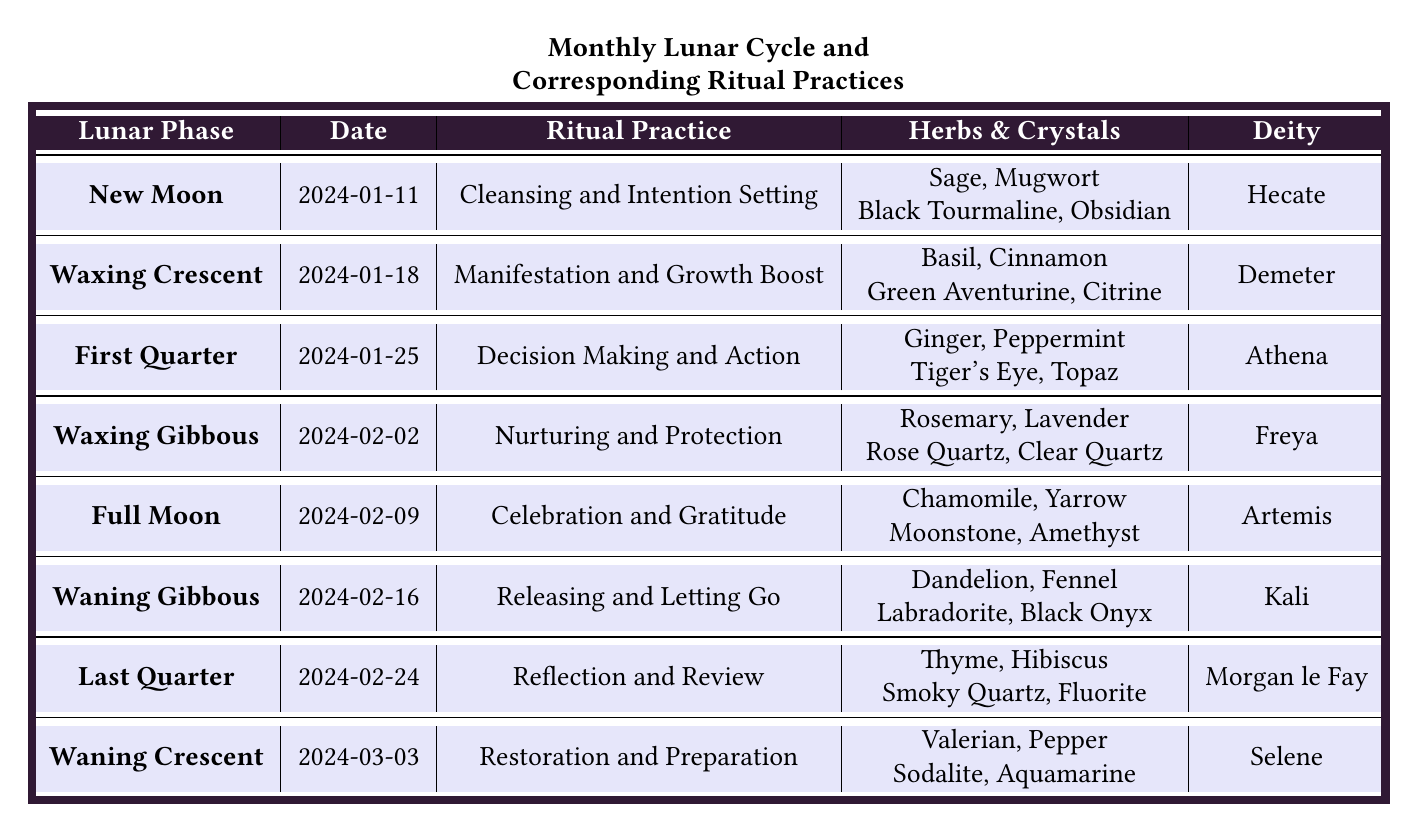What is the ritual practice associated with the Full Moon? The table lists the Full Moon phase with the corresponding ritual practice, which is "Celebration and Gratitude."
Answer: Celebration and Gratitude Which deity is associated with the New Moon? In the table, the New Moon phase is associated with the deity Hecate.
Answer: Hecate What herbs are used during the Waxing Gibbous phase? The table specifies that during the Waxing Gibbous phase, the herbs used are Rosemary and Lavender.
Answer: Rosemary, Lavender How many different crystals are listed for the Waning Crescent? The Waning Crescent phase mentions two crystals: Sodalite and Aquamarine. There are two crystals.
Answer: 2 Is the ritual practice for the First Quarter focused on nurturing? By examining the table, the ritual practice for the First Quarter is "Decision Making and Action," which is not focused on nurturing.
Answer: No What are the corresponding colors for the Waxing Crescent phase? The color information for the Waxing Crescent phase is given as Green and Silver in the table.
Answer: Green, Silver Which lunar phase occurs on February 16, 2024? The table indicates that on February 16, 2024, the phase is the Waning Gibbous.
Answer: Waning Gibbous What is unique about the herbs used in the Last Quarter phase compared to the New Moon? The herbs used for the Last Quarter phase are Thyme and Hibiscus, while the New Moon phase uses Sage and Mugwort, indicating that different types of herbs are utilized in each phase.
Answer: Different herbs used Which lunar phase has the ritual practice of Restoration and Preparation? From the table, the ritual practice of Restoration and Preparation is associated with the Waning Crescent lunar phase.
Answer: Waning Crescent How many phases have "letting go" or "release" oriented practices? The table reveals that there are two such practices: the Waning Gibbous phase (Releasing and Letting Go) and the Waning Crescent phase (Restoration and Preparation), which involves preparation for new intentions.
Answer: 2 Which phase is associated with the deity Selene, and what is its ritual practice? The Waning Crescent phase is associated with the deity Selene, and its ritual practice is "Restoration and Preparation."
Answer: Waning Crescent, Restoration and Preparation 